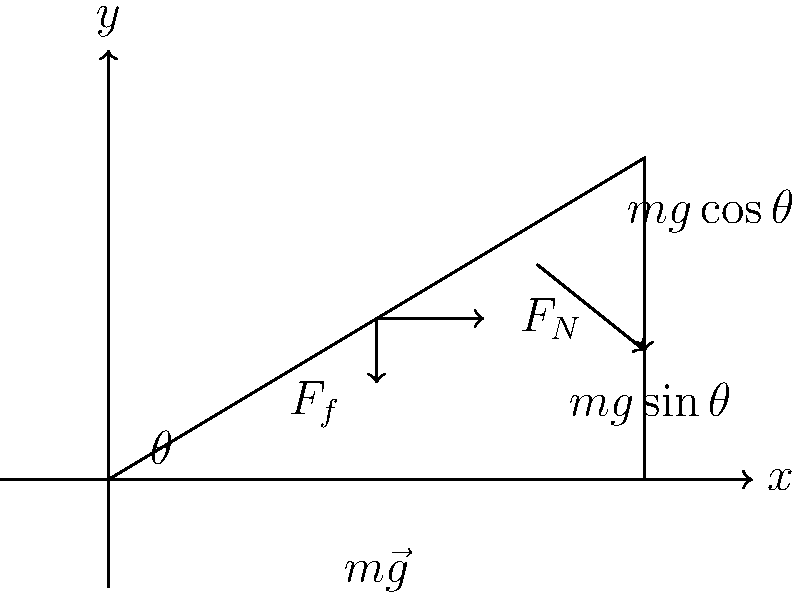Consider an object of mass $m$ resting on an inclined plane with angle $\theta$ to the horizontal. The coefficient of static friction between the object and the plane is $\mu_s$. Determine the maximum angle $\theta_{max}$ at which the object will remain at rest on the inclined plane. Express your answer in terms of $\mu_s$. To solve this problem, we'll follow these steps:

1) Identify the forces acting on the object:
   - Weight ($m\vec{g}$)
   - Normal force ($\vec{F_N}$)
   - Friction force ($\vec{F_f}$)

2) Resolve the weight vector into components parallel and perpendicular to the inclined plane:
   - Parallel component: $mg\sin\theta$
   - Perpendicular component: $mg\cos\theta$

3) For the object to remain at rest, the friction force must be equal to the parallel component of weight:

   $F_f = mg\sin\theta$

4) The maximum friction force is given by:

   $F_{f,max} = \mu_s F_N$

5) The normal force is equal to the perpendicular component of weight:

   $F_N = mg\cos\theta$

6) Substituting this into the friction force equation:

   $\mu_s mg\cos\theta = mg\sin\theta$

7) Simplify by cancelling $mg$ on both sides:

   $\mu_s \cos\theta = \sin\theta$

8) Divide both sides by $\cos\theta$:

   $\mu_s = \tan\theta$

9) Therefore, the maximum angle is given by:

   $\theta_{max} = \tan^{-1}(\mu_s)$

This is the angle at which the object will be on the verge of sliding down the inclined plane.
Answer: $\theta_{max} = \tan^{-1}(\mu_s)$ 